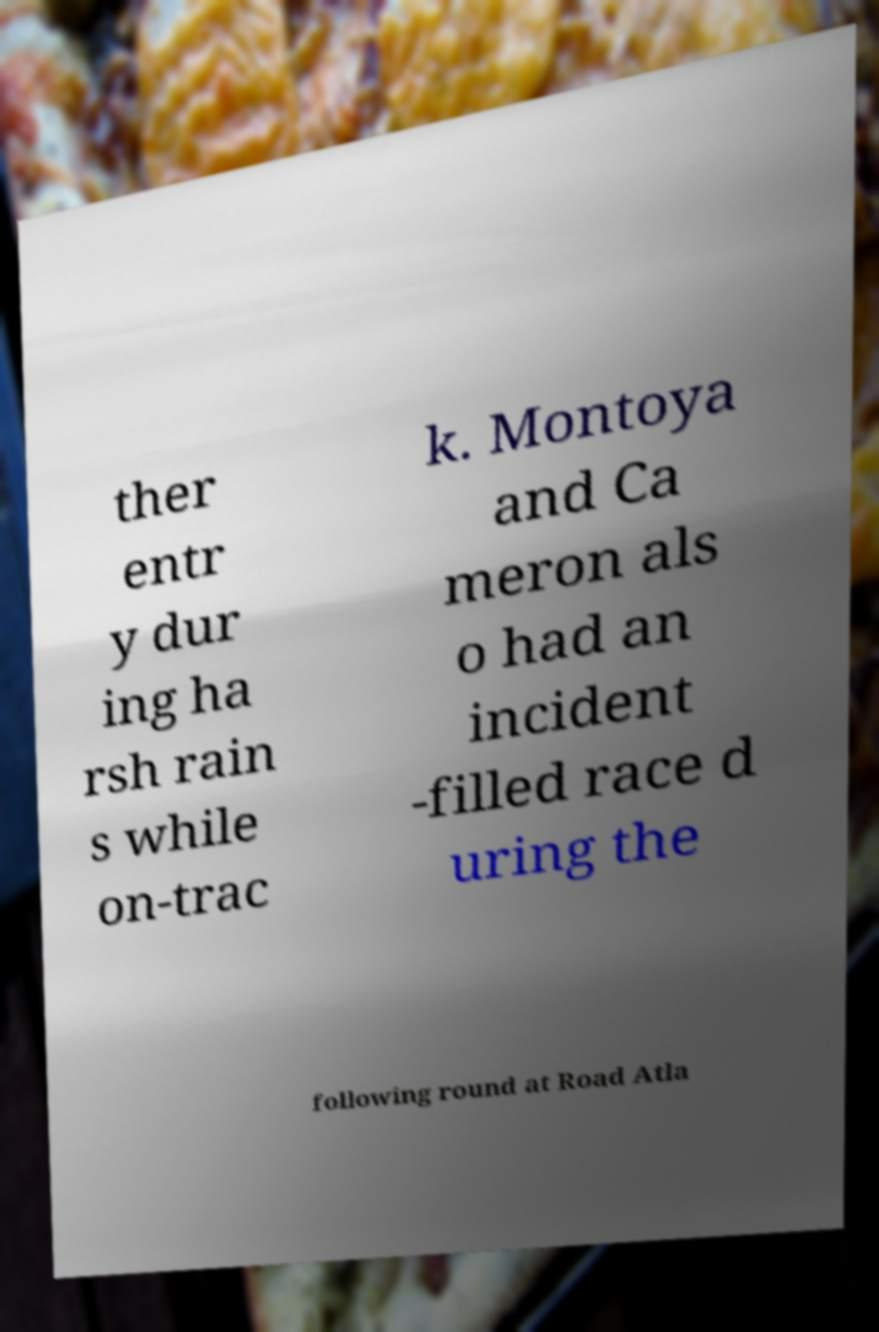For documentation purposes, I need the text within this image transcribed. Could you provide that? ther entr y dur ing ha rsh rain s while on-trac k. Montoya and Ca meron als o had an incident -filled race d uring the following round at Road Atla 